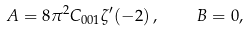Convert formula to latex. <formula><loc_0><loc_0><loc_500><loc_500>A = 8 \pi ^ { 2 } C _ { 0 0 1 } \zeta ^ { \prime } ( - 2 ) \, , \quad B = 0 ,</formula> 